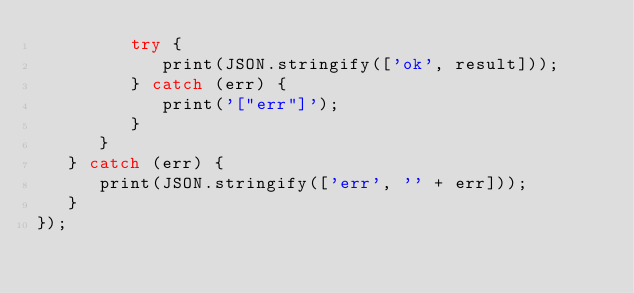<code> <loc_0><loc_0><loc_500><loc_500><_JavaScript_>         try {
            print(JSON.stringify(['ok', result]));
         } catch (err) {
            print('["err"]');
         }
      }
   } catch (err) {
      print(JSON.stringify(['err', '' + err]));
   }
});
</code> 